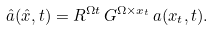Convert formula to latex. <formula><loc_0><loc_0><loc_500><loc_500>\hat { a } ( \hat { x } , t ) = R ^ { \Omega t } \, G ^ { \Omega \times x _ { t } } \, a ( x _ { t } , t ) .</formula> 